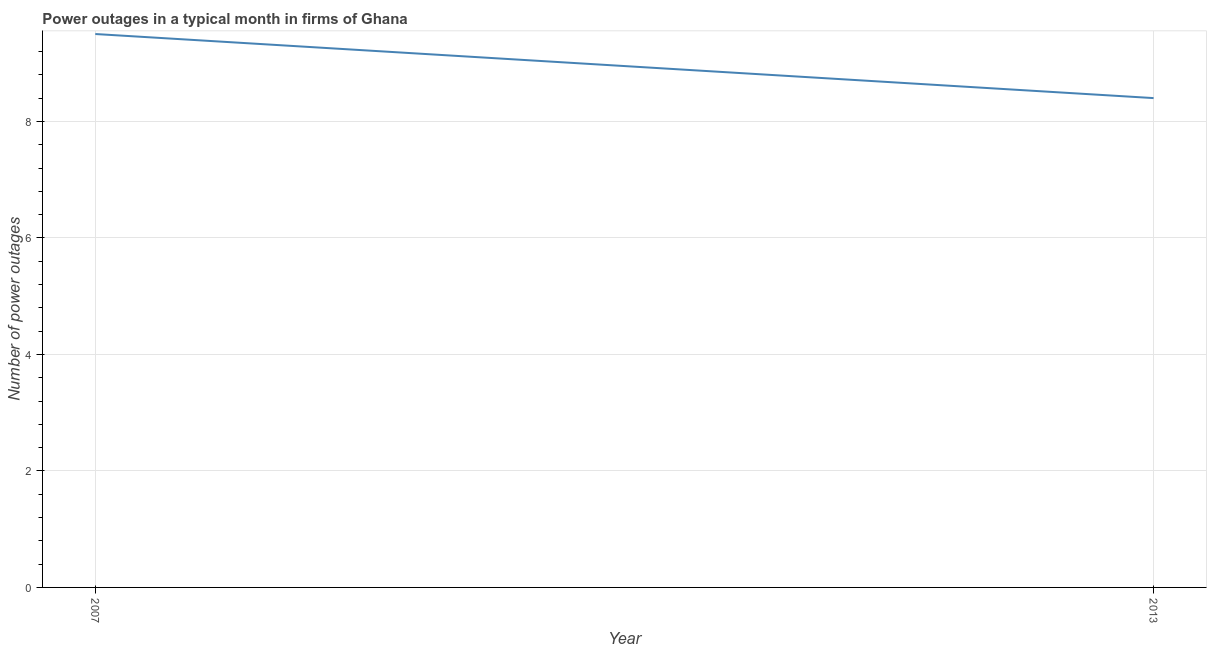Across all years, what is the maximum number of power outages?
Your answer should be very brief. 9.5. Across all years, what is the minimum number of power outages?
Ensure brevity in your answer.  8.4. What is the difference between the number of power outages in 2007 and 2013?
Provide a short and direct response. 1.1. What is the average number of power outages per year?
Give a very brief answer. 8.95. What is the median number of power outages?
Provide a succinct answer. 8.95. What is the ratio of the number of power outages in 2007 to that in 2013?
Your response must be concise. 1.13. How many years are there in the graph?
Offer a terse response. 2. What is the difference between two consecutive major ticks on the Y-axis?
Provide a succinct answer. 2. Does the graph contain any zero values?
Your answer should be compact. No. Does the graph contain grids?
Give a very brief answer. Yes. What is the title of the graph?
Keep it short and to the point. Power outages in a typical month in firms of Ghana. What is the label or title of the X-axis?
Give a very brief answer. Year. What is the label or title of the Y-axis?
Offer a very short reply. Number of power outages. What is the difference between the Number of power outages in 2007 and 2013?
Offer a terse response. 1.1. What is the ratio of the Number of power outages in 2007 to that in 2013?
Your answer should be compact. 1.13. 